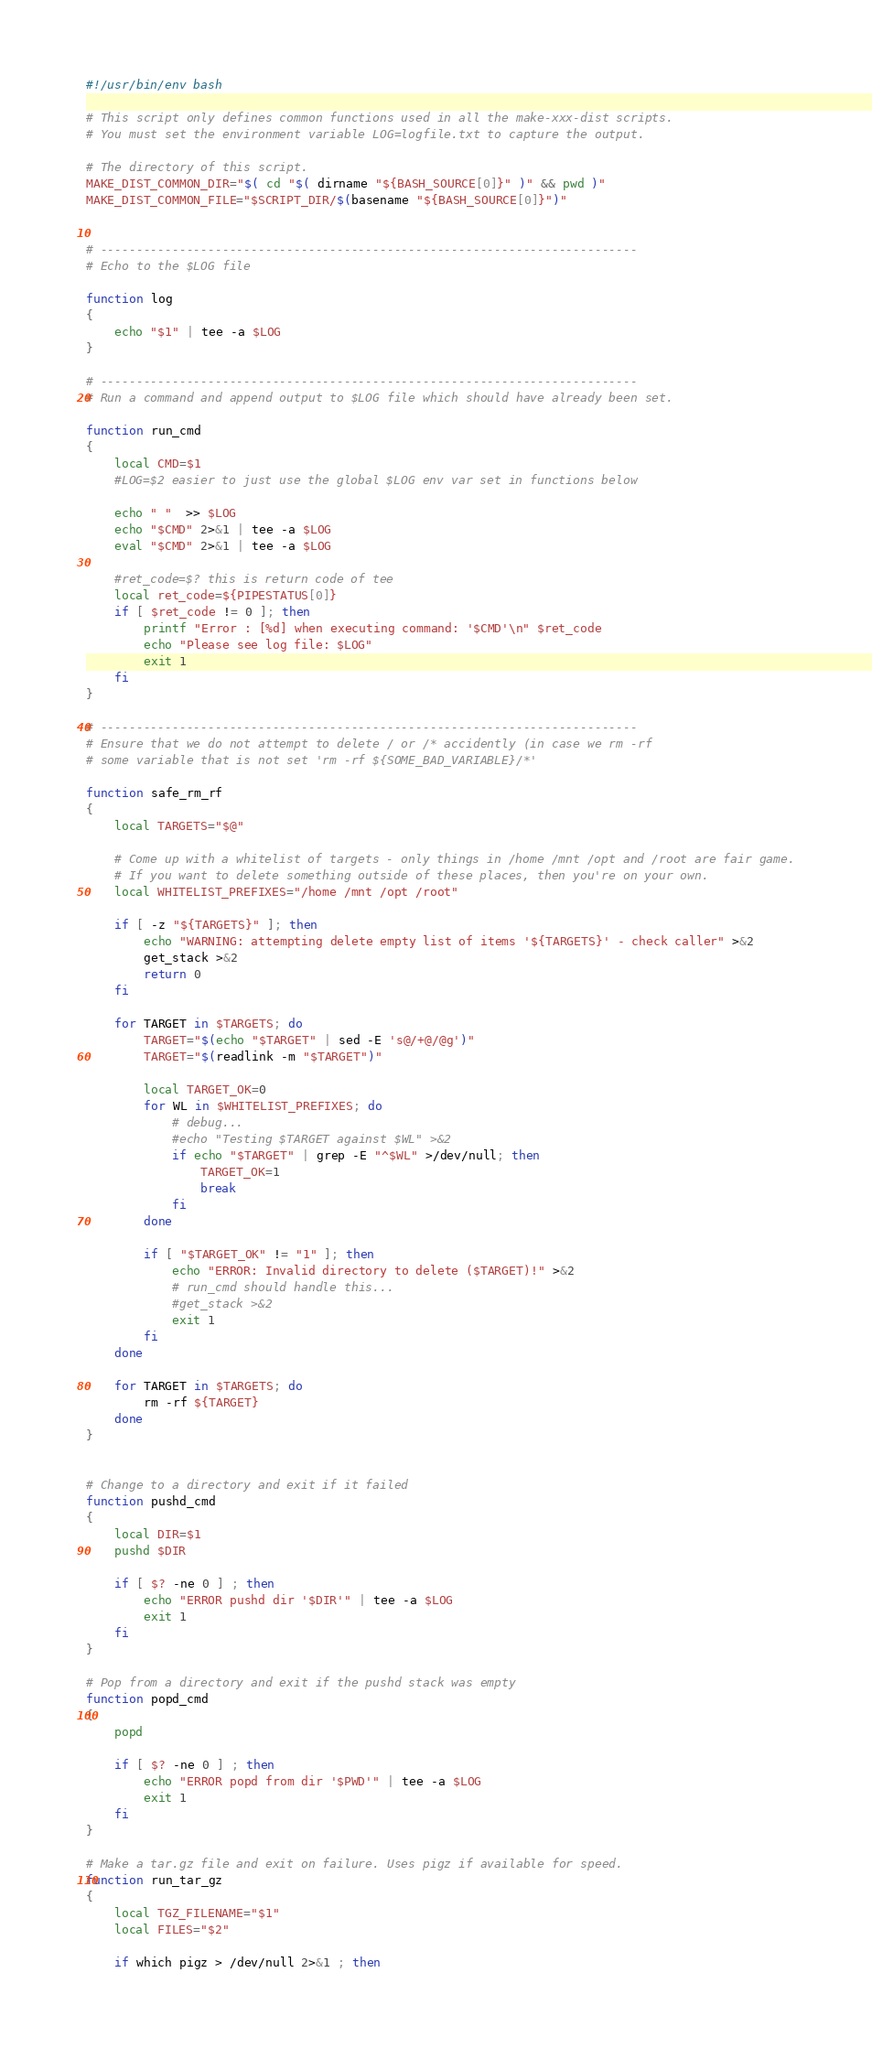Convert code to text. <code><loc_0><loc_0><loc_500><loc_500><_Bash_>#!/usr/bin/env bash

# This script only defines common functions used in all the make-xxx-dist scripts.
# You must set the environment variable LOG=logfile.txt to capture the output.

# The directory of this script.
MAKE_DIST_COMMON_DIR="$( cd "$( dirname "${BASH_SOURCE[0]}" )" && pwd )"
MAKE_DIST_COMMON_FILE="$SCRIPT_DIR/$(basename "${BASH_SOURCE[0]}")"


# ---------------------------------------------------------------------------
# Echo to the $LOG file

function log
{
    echo "$1" | tee -a $LOG
}

# ---------------------------------------------------------------------------
# Run a command and append output to $LOG file which should have already been set.

function run_cmd
{
    local CMD=$1
    #LOG=$2 easier to just use the global $LOG env var set in functions below

    echo " "  >> $LOG
    echo "$CMD" 2>&1 | tee -a $LOG
    eval "$CMD" 2>&1 | tee -a $LOG

    #ret_code=$? this is return code of tee
    local ret_code=${PIPESTATUS[0]}
    if [ $ret_code != 0 ]; then
        printf "Error : [%d] when executing command: '$CMD'\n" $ret_code
        echo "Please see log file: $LOG"
        exit 1
    fi
}

# ---------------------------------------------------------------------------
# Ensure that we do not attempt to delete / or /* accidently (in case we rm -rf
# some variable that is not set 'rm -rf ${SOME_BAD_VARIABLE}/*'

function safe_rm_rf
{
    local TARGETS="$@"

    # Come up with a whitelist of targets - only things in /home /mnt /opt and /root are fair game.
    # If you want to delete something outside of these places, then you're on your own.
    local WHITELIST_PREFIXES="/home /mnt /opt /root"

    if [ -z "${TARGETS}" ]; then
        echo "WARNING: attempting delete empty list of items '${TARGETS}' - check caller" >&2
        get_stack >&2
        return 0
    fi

    for TARGET in $TARGETS; do
        TARGET="$(echo "$TARGET" | sed -E 's@/+@/@g')"
        TARGET="$(readlink -m "$TARGET")"

        local TARGET_OK=0
        for WL in $WHITELIST_PREFIXES; do
            # debug...
            #echo "Testing $TARGET against $WL" >&2
            if echo "$TARGET" | grep -E "^$WL" >/dev/null; then
                TARGET_OK=1
                break
            fi
        done

        if [ "$TARGET_OK" != "1" ]; then
            echo "ERROR: Invalid directory to delete ($TARGET)!" >&2
            # run_cmd should handle this...
            #get_stack >&2
            exit 1
        fi
    done

    for TARGET in $TARGETS; do
        rm -rf ${TARGET}
    done
}


# Change to a directory and exit if it failed
function pushd_cmd
{
    local DIR=$1
    pushd $DIR

    if [ $? -ne 0 ] ; then
        echo "ERROR pushd dir '$DIR'" | tee -a $LOG
        exit 1
    fi
}

# Pop from a directory and exit if the pushd stack was empty
function popd_cmd
{
    popd

    if [ $? -ne 0 ] ; then
        echo "ERROR popd from dir '$PWD'" | tee -a $LOG
        exit 1
    fi
}

# Make a tar.gz file and exit on failure. Uses pigz if available for speed.
function run_tar_gz
{
    local TGZ_FILENAME="$1"
    local FILES="$2"

    if which pigz > /dev/null 2>&1 ; then</code> 